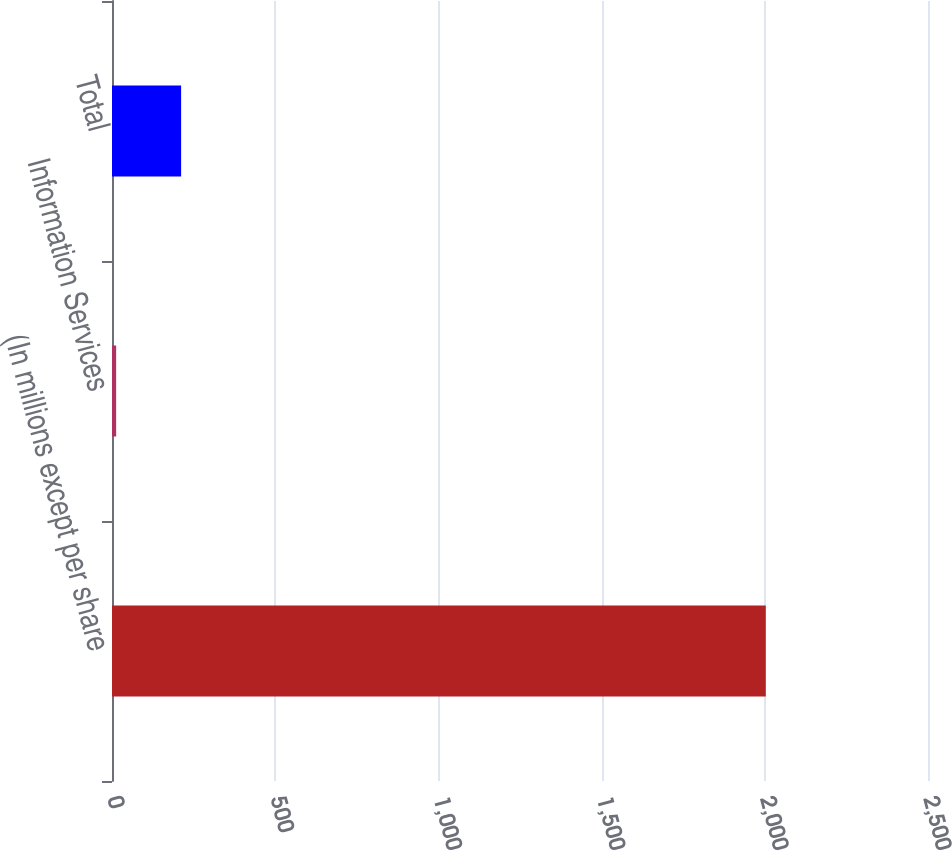Convert chart to OTSL. <chart><loc_0><loc_0><loc_500><loc_500><bar_chart><fcel>(In millions except per share<fcel>Information Services<fcel>Total<nl><fcel>2003<fcel>12.7<fcel>211.73<nl></chart> 